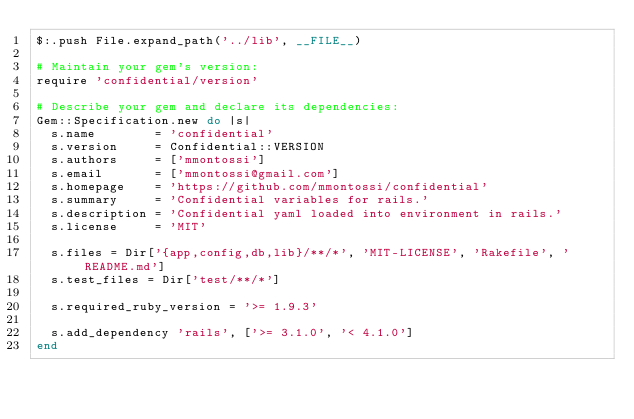<code> <loc_0><loc_0><loc_500><loc_500><_Ruby_>$:.push File.expand_path('../lib', __FILE__)

# Maintain your gem's version:
require 'confidential/version'

# Describe your gem and declare its dependencies:
Gem::Specification.new do |s|
  s.name        = 'confidential'
  s.version     = Confidential::VERSION
  s.authors     = ['mmontossi']
  s.email       = ['mmontossi@gmail.com']
  s.homepage    = 'https://github.com/mmontossi/confidential'
  s.summary     = 'Confidential variables for rails.'
  s.description = 'Confidential yaml loaded into environment in rails.'
  s.license     = 'MIT'

  s.files = Dir['{app,config,db,lib}/**/*', 'MIT-LICENSE', 'Rakefile', 'README.md']
  s.test_files = Dir['test/**/*']

  s.required_ruby_version = '>= 1.9.3'

  s.add_dependency 'rails', ['>= 3.1.0', '< 4.1.0']
end
</code> 